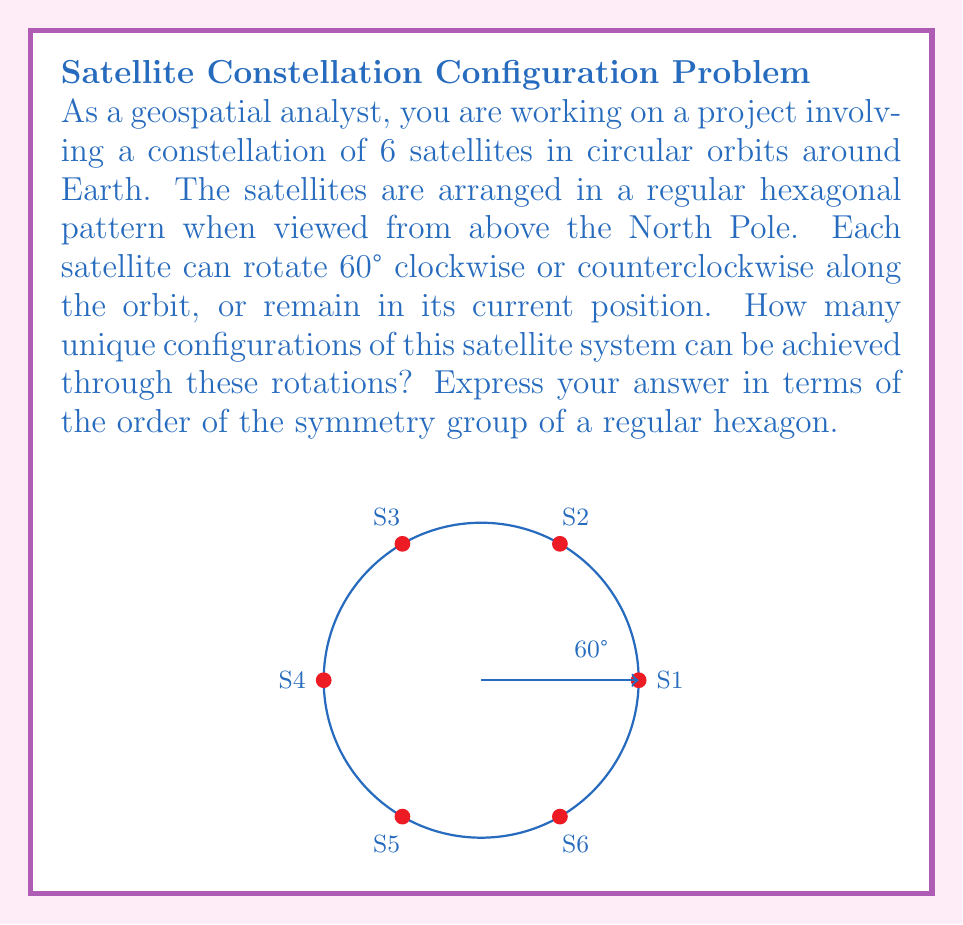Could you help me with this problem? Let's approach this step-by-step:

1) First, we need to recognize that the symmetry group of a regular hexagon is the dihedral group $D_6$, which has order 12.

2) The rotations of each satellite by 60° clockwise, 60° counterclockwise, or remaining stationary form a cyclic group of order 3, which we can call $C_3$.

3) Since we have 6 satellites, each with 3 possible states, we might initially think the total number of configurations is $3^6 = 729$. However, this overcounts the unique configurations.

4) The key insight is that rotating all satellites by 60° clockwise is equivalent to rotating the entire constellation by 60° counterclockwise, which brings us back to a configuration that's symmetrically equivalent to the starting position.

5) In group theory terms, we can express this as the wreath product of $C_3$ and $D_6$, denoted as $C_3 \wr D_6$.

6) The order of this wreath product is given by:

   $|C_3 \wr D_6| = |C_3|^{|D_6|} / |D_6| = 3^{12} / 12$

7) This accounts for all possible configurations, factoring out the redundancies due to the overall rotational symmetry of the constellation.

Therefore, the number of unique configurations is $3^{12} / 12$, or $531,441 / 12 = 44,286.75$. Since we're dealing with discrete configurations, we round down to the nearest whole number.
Answer: $\frac{3^{|D_6|}}{|D_6|} - 1 = 44,286$ 